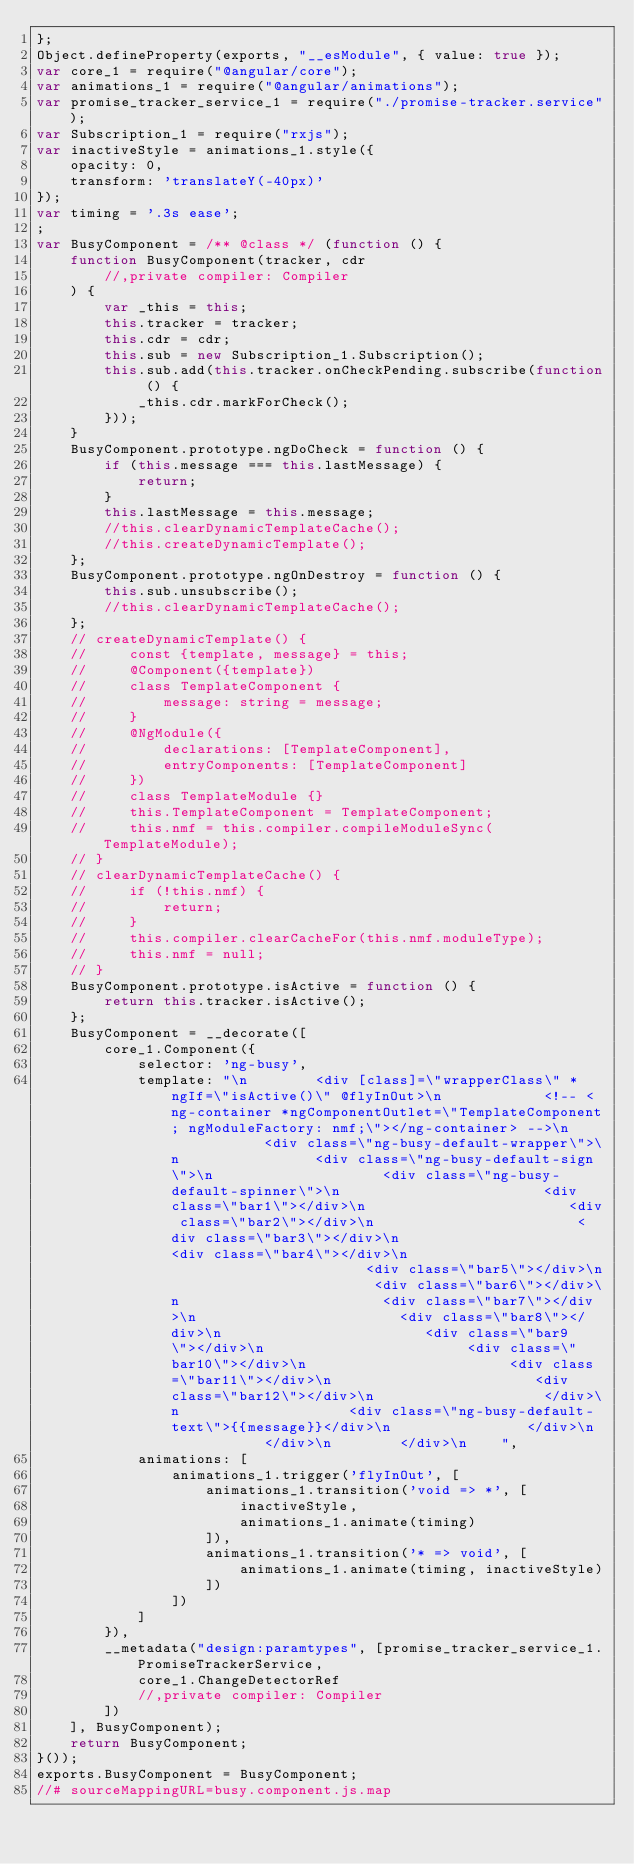<code> <loc_0><loc_0><loc_500><loc_500><_JavaScript_>};
Object.defineProperty(exports, "__esModule", { value: true });
var core_1 = require("@angular/core");
var animations_1 = require("@angular/animations");
var promise_tracker_service_1 = require("./promise-tracker.service");
var Subscription_1 = require("rxjs");
var inactiveStyle = animations_1.style({
    opacity: 0,
    transform: 'translateY(-40px)'
});
var timing = '.3s ease';
;
var BusyComponent = /** @class */ (function () {
    function BusyComponent(tracker, cdr
        //,private compiler: Compiler
    ) {
        var _this = this;
        this.tracker = tracker;
        this.cdr = cdr;
        this.sub = new Subscription_1.Subscription();
        this.sub.add(this.tracker.onCheckPending.subscribe(function () {
            _this.cdr.markForCheck();
        }));
    }
    BusyComponent.prototype.ngDoCheck = function () {
        if (this.message === this.lastMessage) {
            return;
        }
        this.lastMessage = this.message;
        //this.clearDynamicTemplateCache();
        //this.createDynamicTemplate();
    };
    BusyComponent.prototype.ngOnDestroy = function () {
        this.sub.unsubscribe();
        //this.clearDynamicTemplateCache();
    };
    // createDynamicTemplate() {
    //     const {template, message} = this;
    //     @Component({template})
    //     class TemplateComponent {
    //         message: string = message;
    //     }
    //     @NgModule({
    //         declarations: [TemplateComponent],
    //         entryComponents: [TemplateComponent]
    //     })
    //     class TemplateModule {}
    //     this.TemplateComponent = TemplateComponent;
    //     this.nmf = this.compiler.compileModuleSync(TemplateModule);
    // }
    // clearDynamicTemplateCache() {
    //     if (!this.nmf) {
    //         return;
    //     }
    //     this.compiler.clearCacheFor(this.nmf.moduleType);
    //     this.nmf = null;
    // }
    BusyComponent.prototype.isActive = function () {
        return this.tracker.isActive();
    };
    BusyComponent = __decorate([
        core_1.Component({
            selector: 'ng-busy',
            template: "\n        <div [class]=\"wrapperClass\" *ngIf=\"isActive()\" @flyInOut>\n            <!-- <ng-container *ngComponentOutlet=\"TemplateComponent; ngModuleFactory: nmf;\"></ng-container> -->\n            <div class=\"ng-busy-default-wrapper\">\n                <div class=\"ng-busy-default-sign\">\n                    <div class=\"ng-busy-default-spinner\">\n                        <div class=\"bar1\"></div>\n                        <div class=\"bar2\"></div>\n                        <div class=\"bar3\"></div>\n                        <div class=\"bar4\"></div>\n                        <div class=\"bar5\"></div>\n                        <div class=\"bar6\"></div>\n                        <div class=\"bar7\"></div>\n                        <div class=\"bar8\"></div>\n                        <div class=\"bar9\"></div>\n                        <div class=\"bar10\"></div>\n                        <div class=\"bar11\"></div>\n                        <div class=\"bar12\"></div>\n                    </div>\n                    <div class=\"ng-busy-default-text\">{{message}}</div>\n                </div>\n            </div>\n        </div>\n    ",
            animations: [
                animations_1.trigger('flyInOut', [
                    animations_1.transition('void => *', [
                        inactiveStyle,
                        animations_1.animate(timing)
                    ]),
                    animations_1.transition('* => void', [
                        animations_1.animate(timing, inactiveStyle)
                    ])
                ])
            ]
        }),
        __metadata("design:paramtypes", [promise_tracker_service_1.PromiseTrackerService,
            core_1.ChangeDetectorRef
            //,private compiler: Compiler
        ])
    ], BusyComponent);
    return BusyComponent;
}());
exports.BusyComponent = BusyComponent;
//# sourceMappingURL=busy.component.js.map</code> 